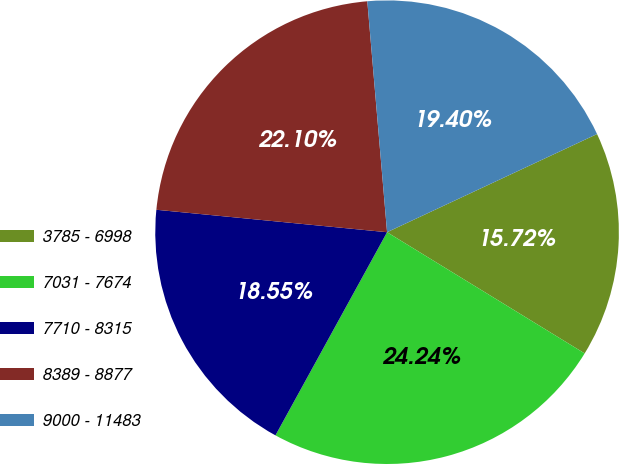Convert chart. <chart><loc_0><loc_0><loc_500><loc_500><pie_chart><fcel>3785 - 6998<fcel>7031 - 7674<fcel>7710 - 8315<fcel>8389 - 8877<fcel>9000 - 11483<nl><fcel>15.72%<fcel>24.24%<fcel>18.55%<fcel>22.1%<fcel>19.4%<nl></chart> 